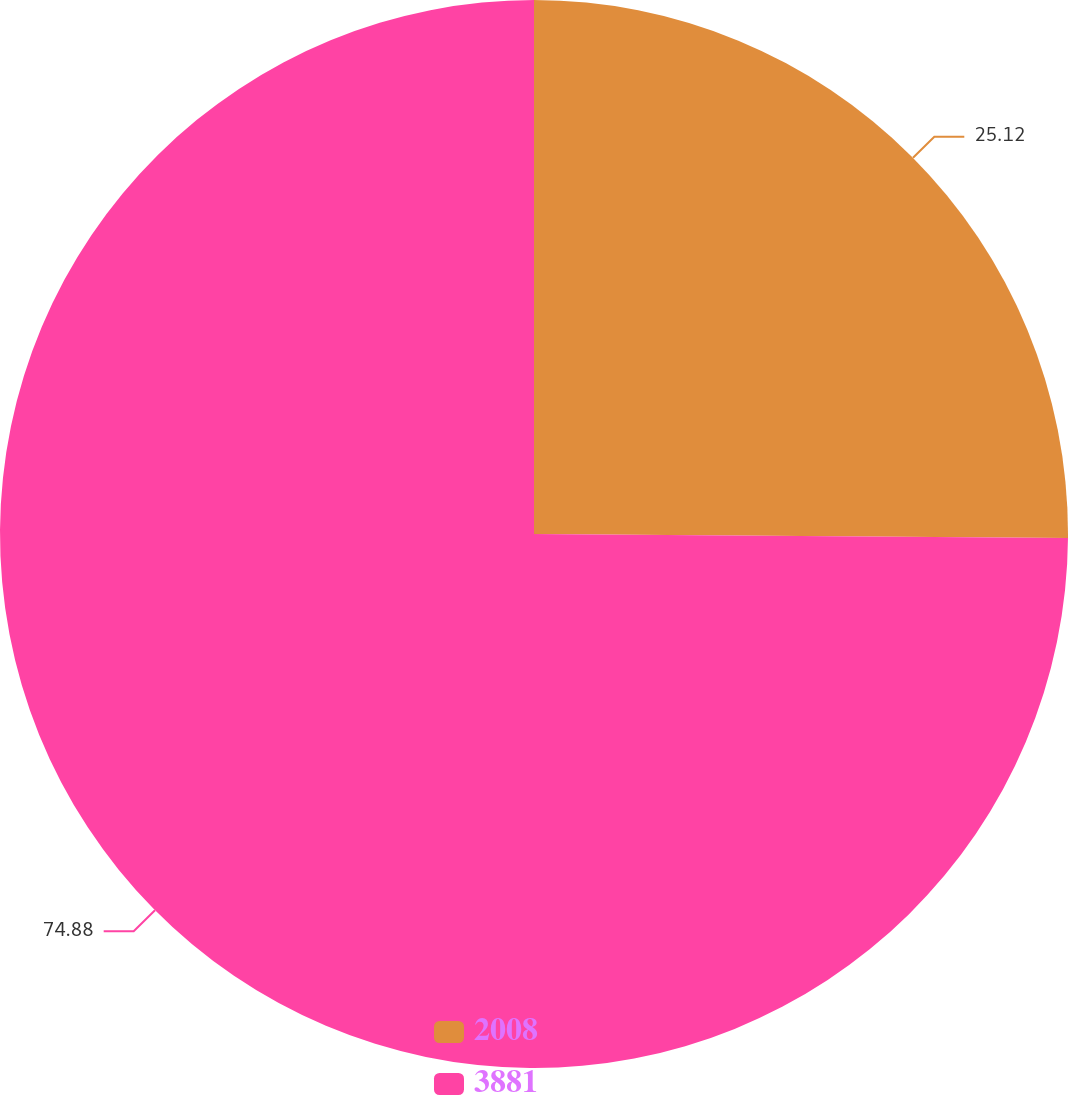<chart> <loc_0><loc_0><loc_500><loc_500><pie_chart><fcel>2008<fcel>3881<nl><fcel>25.12%<fcel>74.88%<nl></chart> 